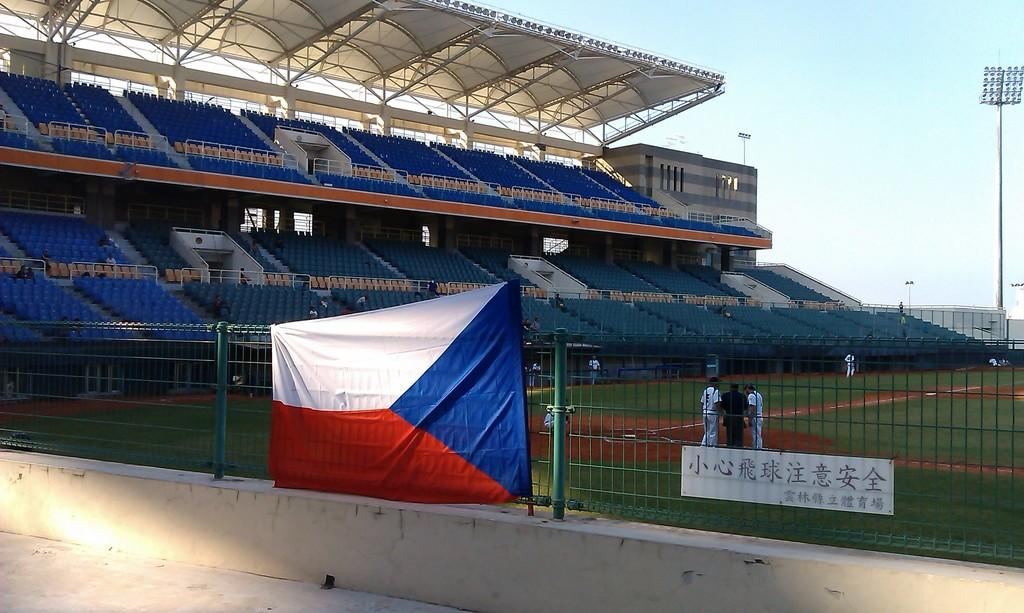<image>
Relay a brief, clear account of the picture shown. Baseball stadium that has chinese letters in the front. 